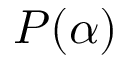Convert formula to latex. <formula><loc_0><loc_0><loc_500><loc_500>P ( \alpha )</formula> 